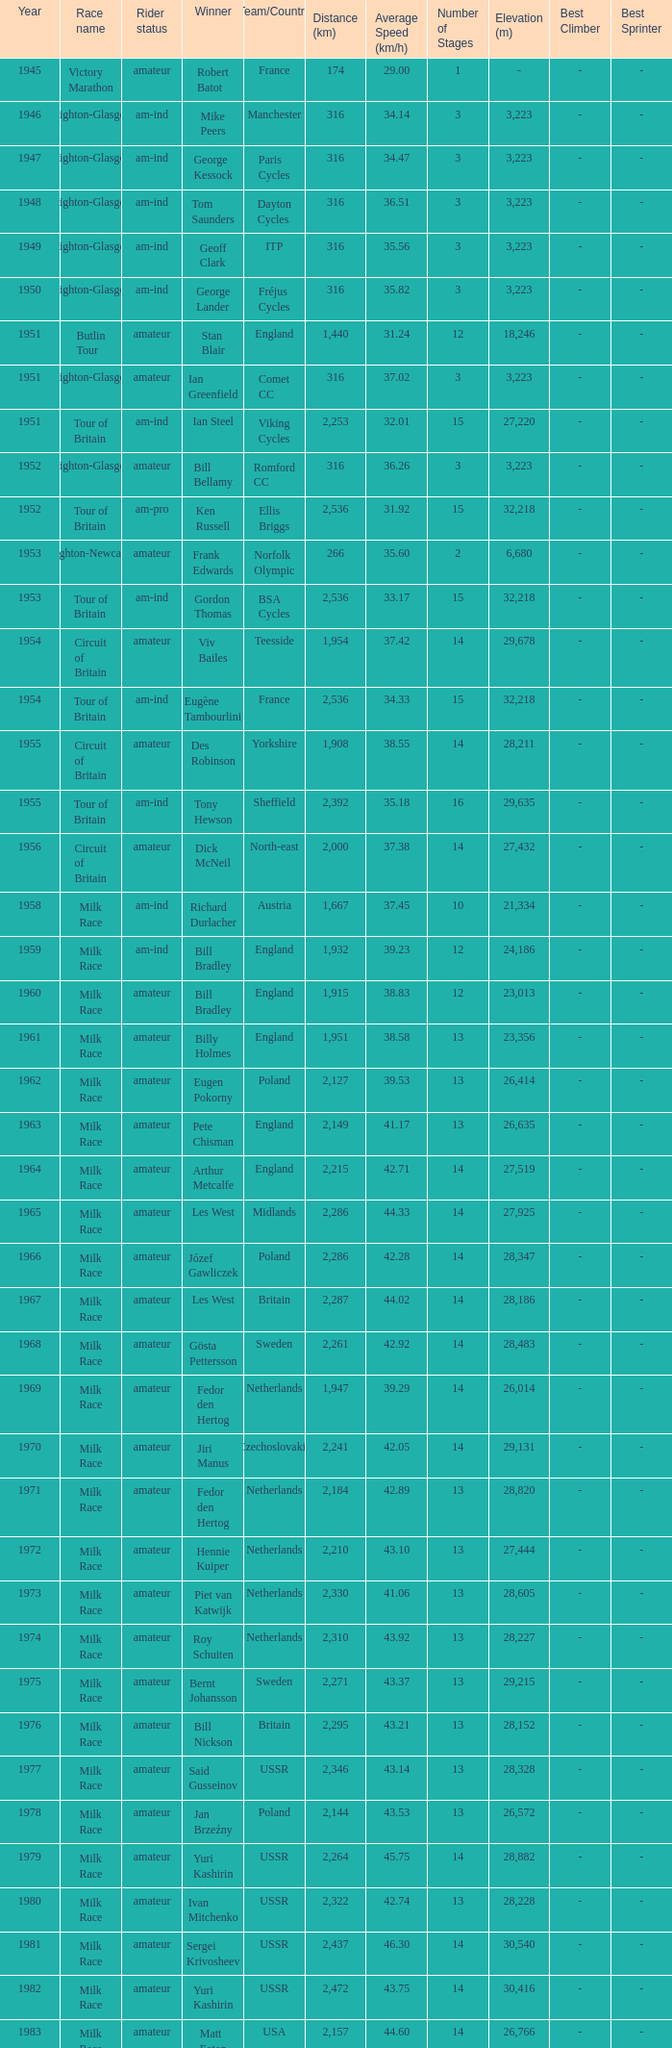What is the rider status for the 1971 netherlands team? Amateur. 